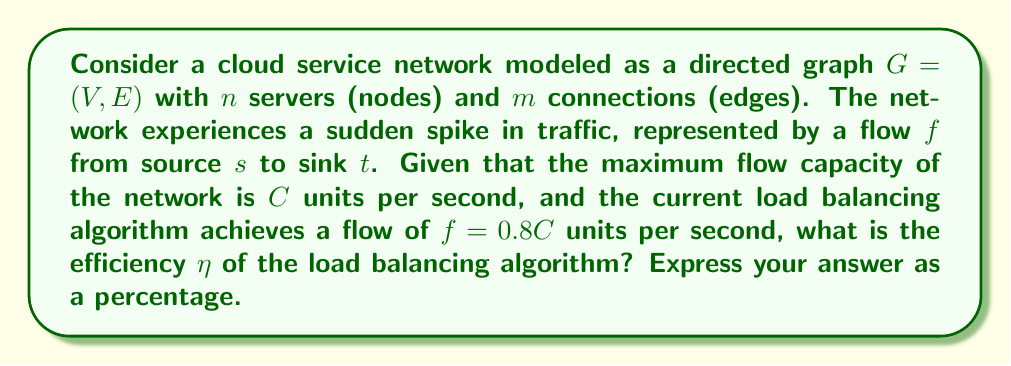Show me your answer to this math problem. To solve this problem, we'll follow these steps:

1) In network flow optimization, efficiency is often measured as the ratio of achieved flow to maximum possible flow. This can be expressed mathematically as:

   $$\eta = \frac{\text{Achieved Flow}}{\text{Maximum Flow}} \times 100\%$$

2) In this case, we're given:
   - Maximum flow capacity: $C$ units per second
   - Achieved flow: $f = 0.8C$ units per second

3) Substituting these values into our efficiency formula:

   $$\eta = \frac{0.8C}{C} \times 100\%$$

4) Simplify the fraction:

   $$\eta = 0.8 \times 100\%$$

5) Calculate the final percentage:

   $$\eta = 80\%$$

Therefore, the efficiency of the load balancing algorithm is 80%.
Answer: 80% 